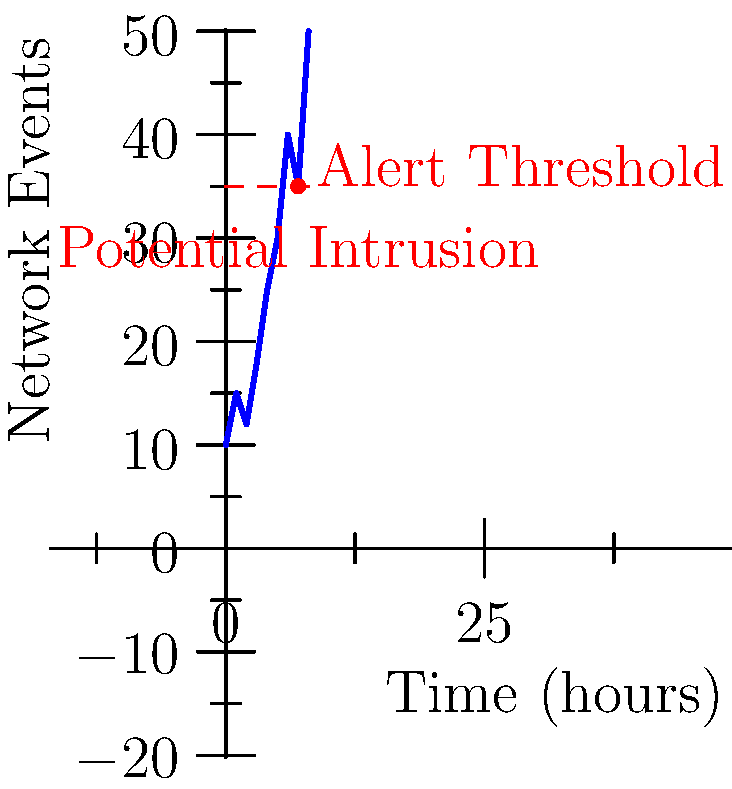Based on the network monitoring graph shown, which represents log analysis over an 8-hour period, at what point does the system detect a potential intrusion that should trigger an alert? To determine when the system detects a potential intrusion, we need to analyze the graph step-by-step:

1. The x-axis represents time in hours, while the y-axis represents the number of network events.
2. The red dashed line indicates the alert threshold, set at 35 events.
3. The blue line represents the actual network events over time.
4. We need to identify where the blue line crosses the red alert threshold line.

Analyzing the graph:
- From 0 to 6 hours, the network events remain below the alert threshold.
- At the 7-hour mark, the blue line intersects with the red dashed line, indicating that the number of events has reached the alert threshold.
- This intersection point is marked with a red dot and labeled "Potential Intrusion."

Therefore, the system detects a potential intrusion that should trigger an alert at the 7-hour mark.
Answer: 7 hours 